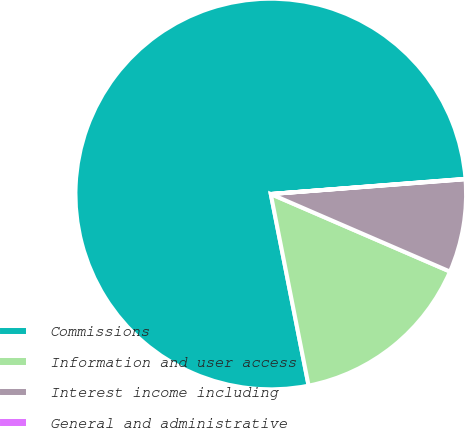<chart> <loc_0><loc_0><loc_500><loc_500><pie_chart><fcel>Commissions<fcel>Information and user access<fcel>Interest income including<fcel>General and administrative<nl><fcel>76.87%<fcel>15.4%<fcel>7.71%<fcel>0.03%<nl></chart> 